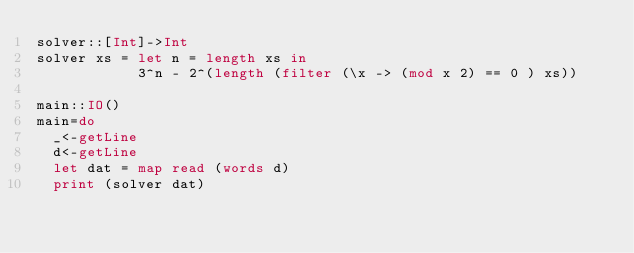<code> <loc_0><loc_0><loc_500><loc_500><_Haskell_>solver::[Int]->Int
solver xs = let n = length xs in
            3^n - 2^(length (filter (\x -> (mod x 2) == 0 ) xs))

main::IO()
main=do
  _<-getLine
  d<-getLine
  let dat = map read (words d)
  print (solver dat)
</code> 